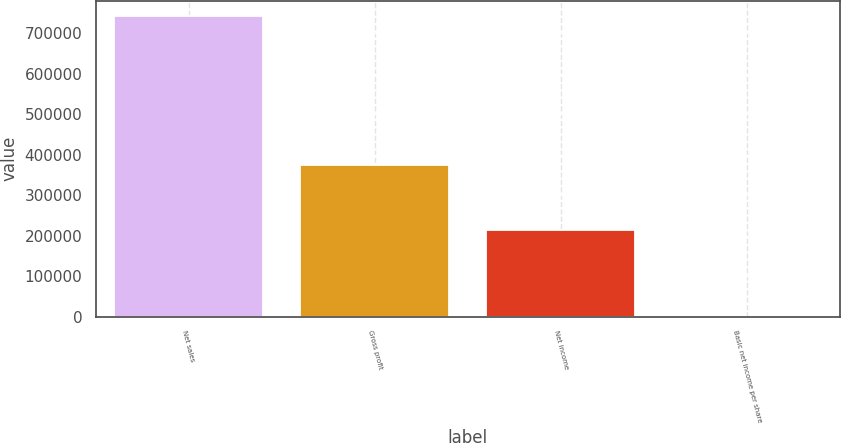Convert chart. <chart><loc_0><loc_0><loc_500><loc_500><bar_chart><fcel>Net sales<fcel>Gross profit<fcel>Net income<fcel>Basic net income per share<nl><fcel>742466<fcel>374667<fcel>214377<fcel>0.99<nl></chart> 